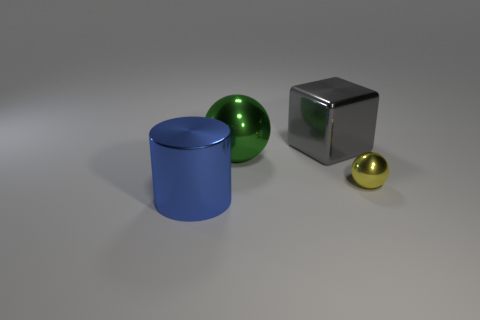There is a big object in front of the metal ball that is left of the sphere that is on the right side of the gray metallic object; what color is it?
Offer a terse response. Blue. What shape is the large gray thing?
Make the answer very short. Cube. There is a tiny ball; is it the same color as the ball that is on the left side of the large block?
Give a very brief answer. No. Is the number of large metal blocks on the left side of the blue cylinder the same as the number of yellow metallic cylinders?
Keep it short and to the point. Yes. What number of things are the same size as the metallic cylinder?
Your answer should be compact. 2. Is there a large purple metallic object?
Your answer should be compact. No. There is a big shiny thing behind the large metal ball; is it the same shape as the big object that is in front of the tiny sphere?
Offer a very short reply. No. How many small objects are either blue metallic cylinders or red cubes?
Give a very brief answer. 0. The green object that is the same material as the yellow thing is what shape?
Ensure brevity in your answer.  Sphere. Do the green shiny thing and the yellow metallic thing have the same shape?
Provide a succinct answer. Yes. 